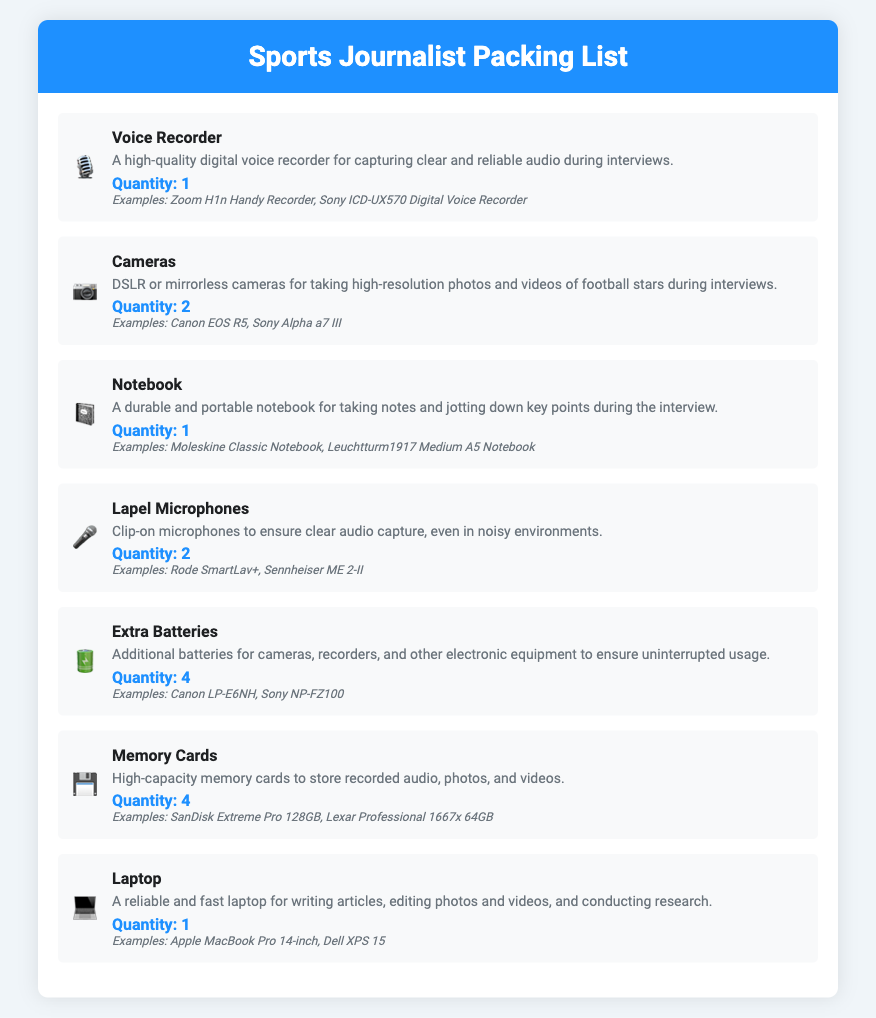What is the quantity of Voice Recorders listed? The document states that there is 1 Voice Recorder included in the packing list.
Answer: 1 How many cameras are recommended to pack? The list specifies that 2 cameras should be packed for the interviews.
Answer: 2 What type of notebook is suggested for note-taking? The document suggests a durable and portable notebook for jotting down key points, specifically examples of Moleskine Classic Notebook.
Answer: Moleskine Classic Notebook How many extra batteries are included in the packing list? The packing list includes 4 extra batteries for various electronic equipment.
Answer: 4 What is one example of a camera provided in the list? The document provides examples of cameras, including the Canon EOS R5.
Answer: Canon EOS R5 Why are lapel microphones included in the equipment list? Lapel microphones are included to ensure clear audio capture, even in noisy environments.
Answer: Clear audio capture What type of laptop is on the packing list? The document mentions a reliable and fast laptop, specifically examples being the Apple MacBook Pro.
Answer: Apple MacBook Pro What is the purpose of memory cards in the packing list? The document states that high-capacity memory cards are meant to store recorded audio, photos, and videos.
Answer: Store recorded audio, photos, and videos 